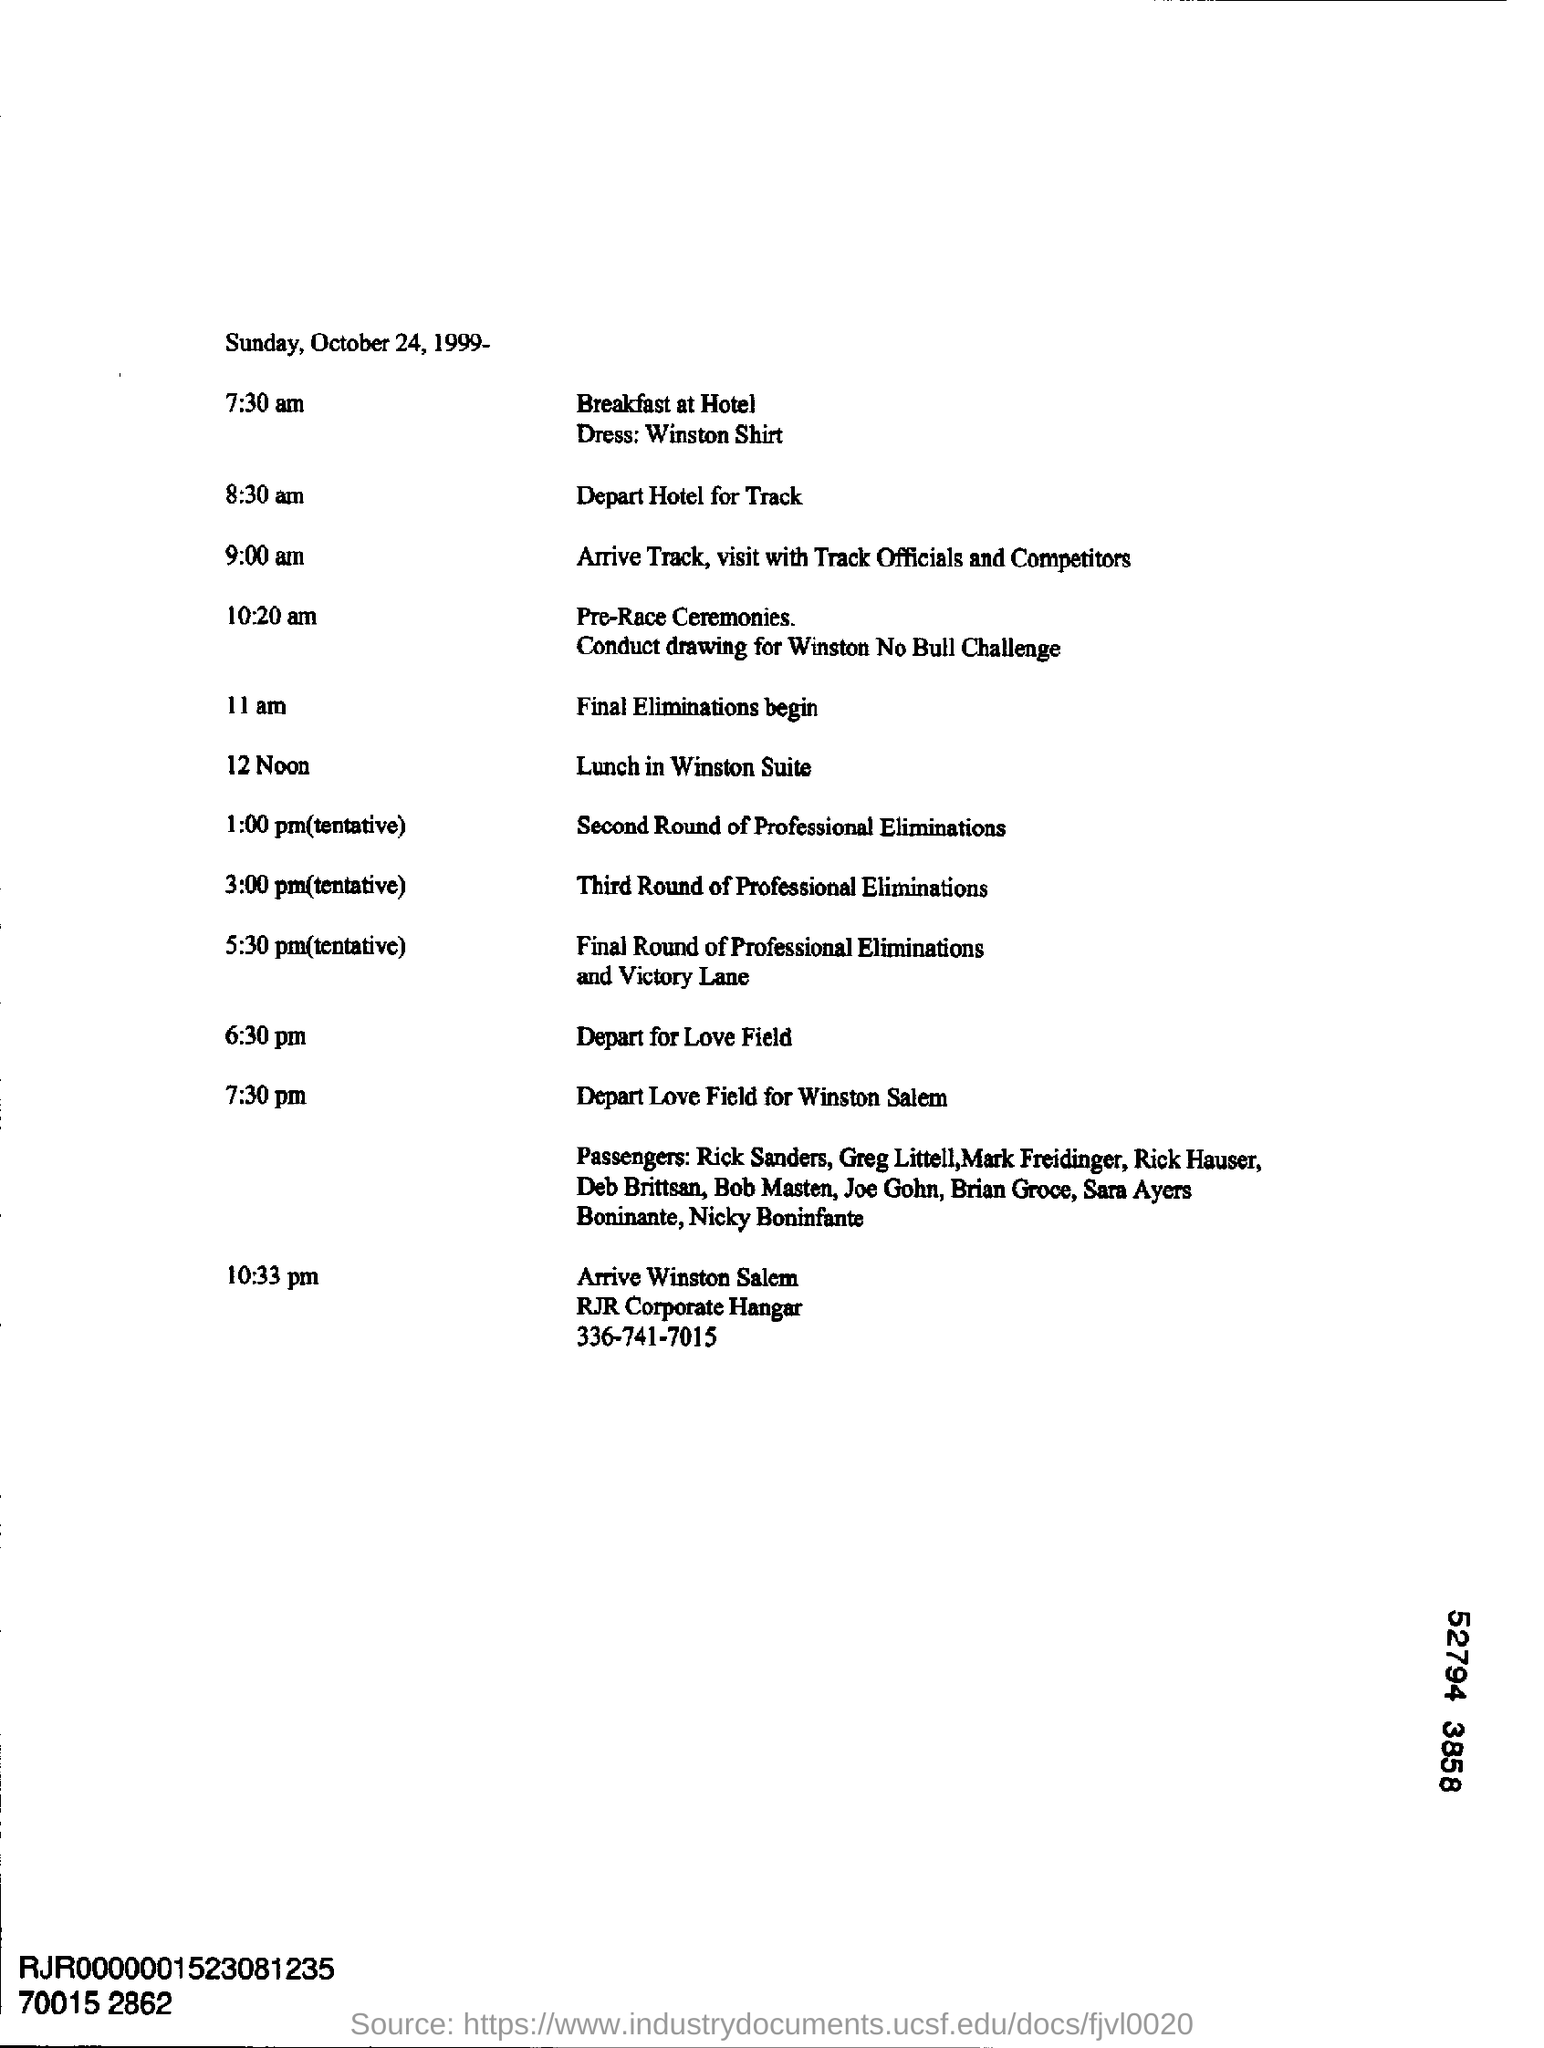List a handful of essential elements in this visual. The document mentions a dress code that requires Winston to wear a shirt. The lunch in the Winston Suite is scheduled for 12 noon. On October 24, 1999, it was a Sunday. 